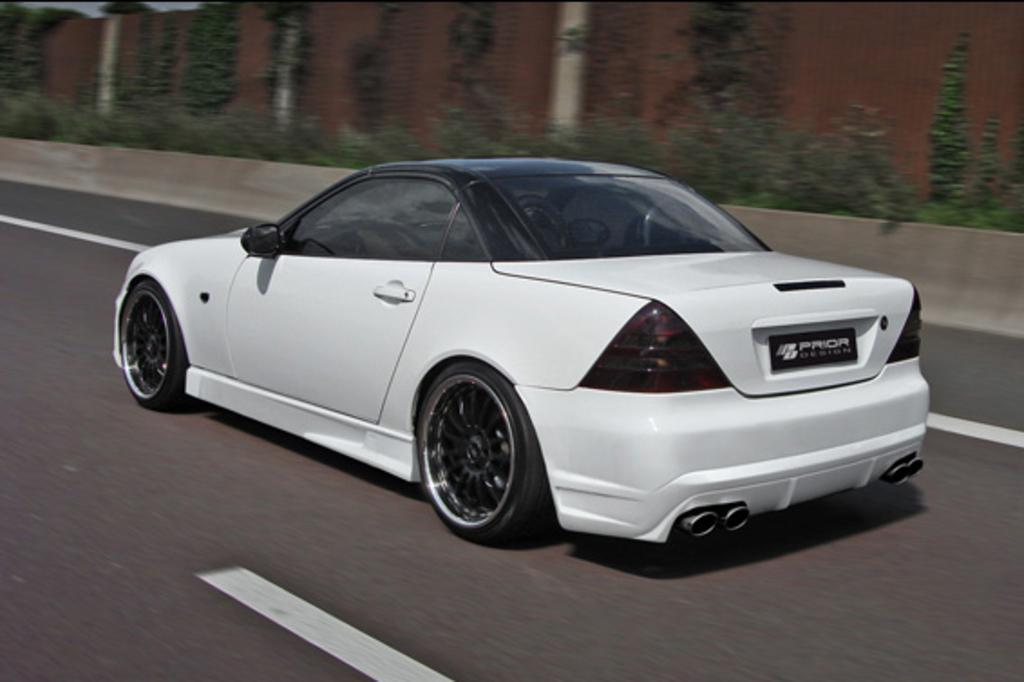What is the main subject in the middle of the picture? There is a car in the middle of the picture. What can be seen in the background of the picture? There are plants and a wall in the background of the picture. Can you see a pig looking at the car in the image? There is no pig present in the image, and therefore no such activity can be observed. 